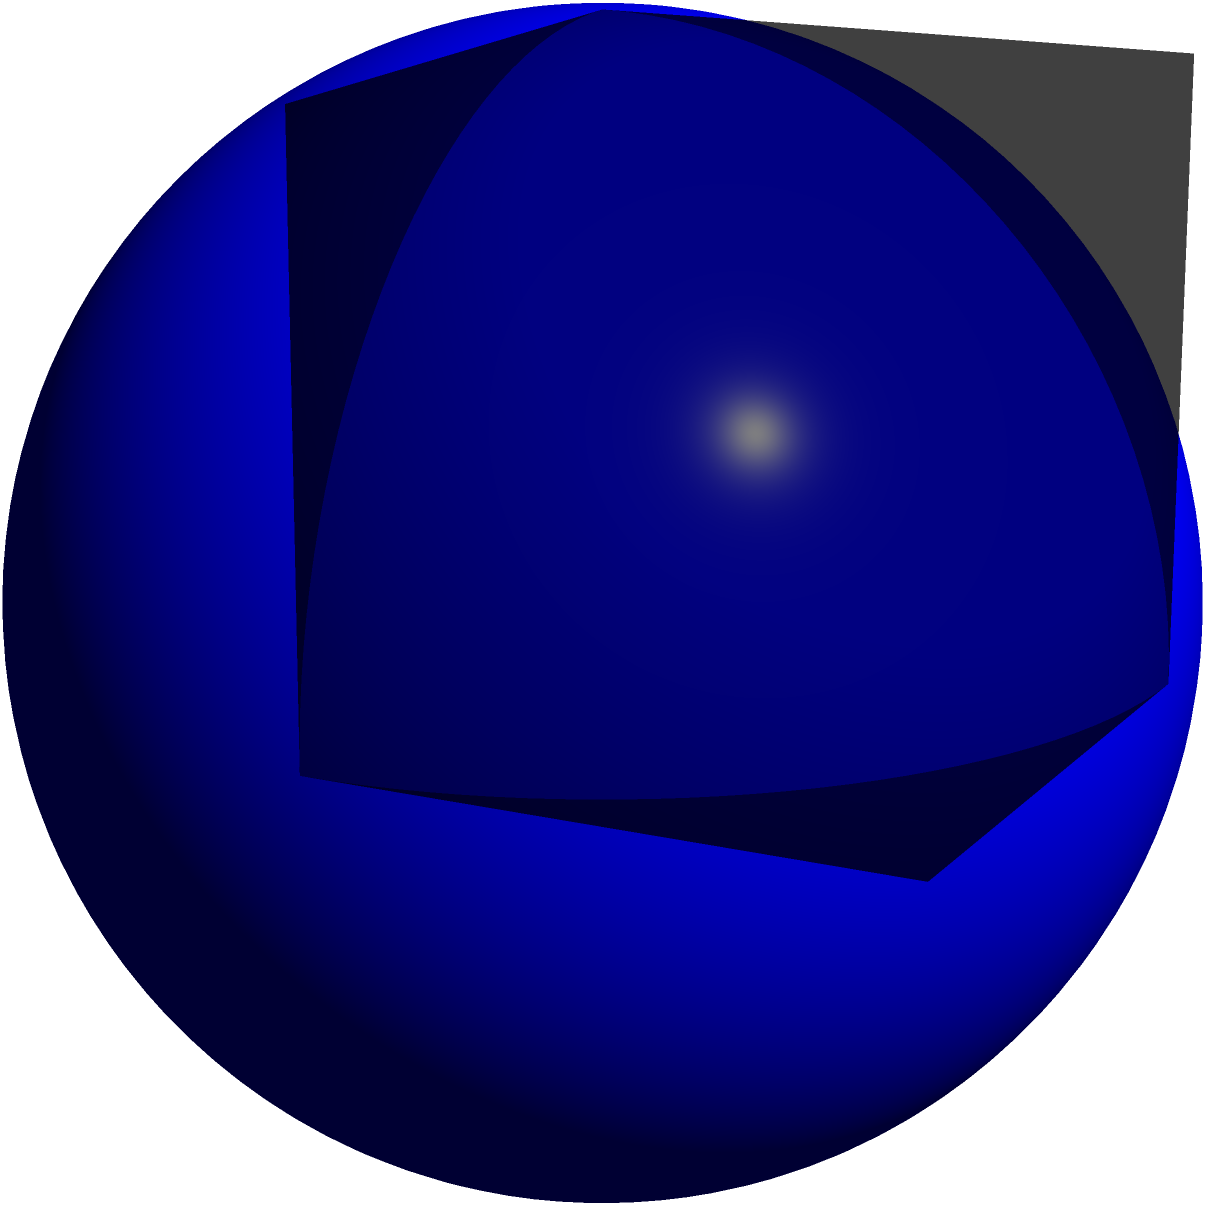In the spirit of unity and interconnectedness, consider a sphere inscribed within a cube. If the edge length of the cube is 10 units, calculate the surface area of the sphere. How might this relationship between the cube and sphere reflect the harmony we seek in interfaith dialogue? Let's approach this step-by-step, reflecting on the beauty of mathematical relationships:

1) First, we need to understand the relationship between the cube and the inscribed sphere:
   - The diameter of the sphere is equal to the edge length of the cube.
   - Therefore, the radius of the sphere is half the edge length of the cube.

2) Given:
   - Edge length of cube = 10 units
   - Radius of sphere = 10/2 = 5 units

3) The formula for the surface area of a sphere is:
   $$ A = 4\pi r^2 $$
   Where $A$ is the surface area and $r$ is the radius.

4) Substituting our radius:
   $$ A = 4\pi (5)^2 $$

5) Simplifying:
   $$ A = 4\pi (25) = 100\pi $$

6) Therefore, the surface area of the sphere is $100\pi$ square units.

This relationship between the cube and sphere can be seen as a metaphor for interfaith dialogue. The cube, with its defined edges and corners, represents our individual faiths and beliefs. The sphere within, touching all sides equally, symbolizes the common core of compassion, love, and understanding that connects all faiths. Just as the sphere's surface area is derived from the cube's dimensions, our capacity for mutual understanding grows from the foundation of our individual beliefs.
Answer: $100\pi$ square units 